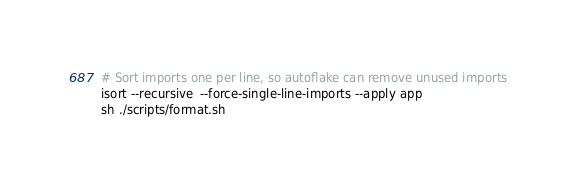<code> <loc_0><loc_0><loc_500><loc_500><_Bash_># Sort imports one per line, so autoflake can remove unused imports
isort --recursive  --force-single-line-imports --apply app
sh ./scripts/format.sh</code> 